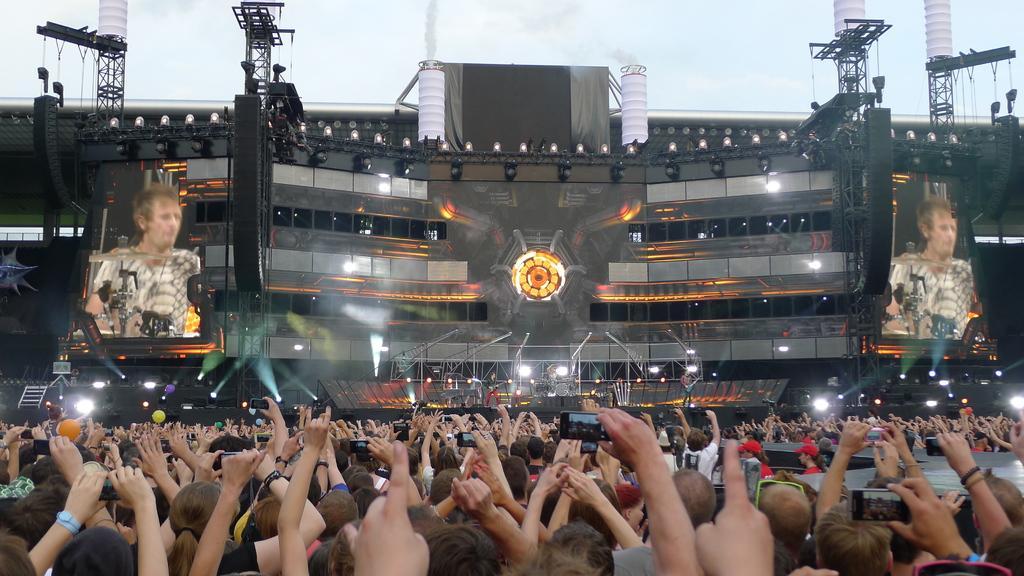Describe this image in one or two sentences. In this picture there are people, among them few people holding gadgets and we can see buildings, lights, screens, rods, smoke and objects. In the background of the image we can see the sky. 